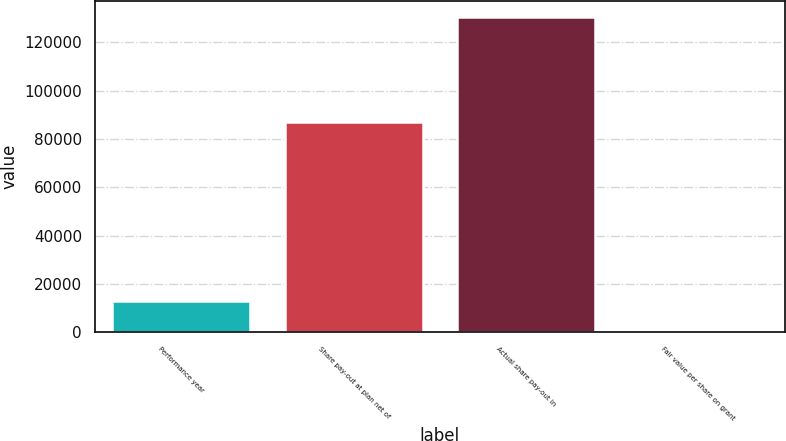<chart> <loc_0><loc_0><loc_500><loc_500><bar_chart><fcel>Performance year<fcel>Share pay-out at plan net of<fcel>Actual share pay-out in<fcel>Fair value per share on grant<nl><fcel>13068.1<fcel>87035<fcel>130552<fcel>14.29<nl></chart> 